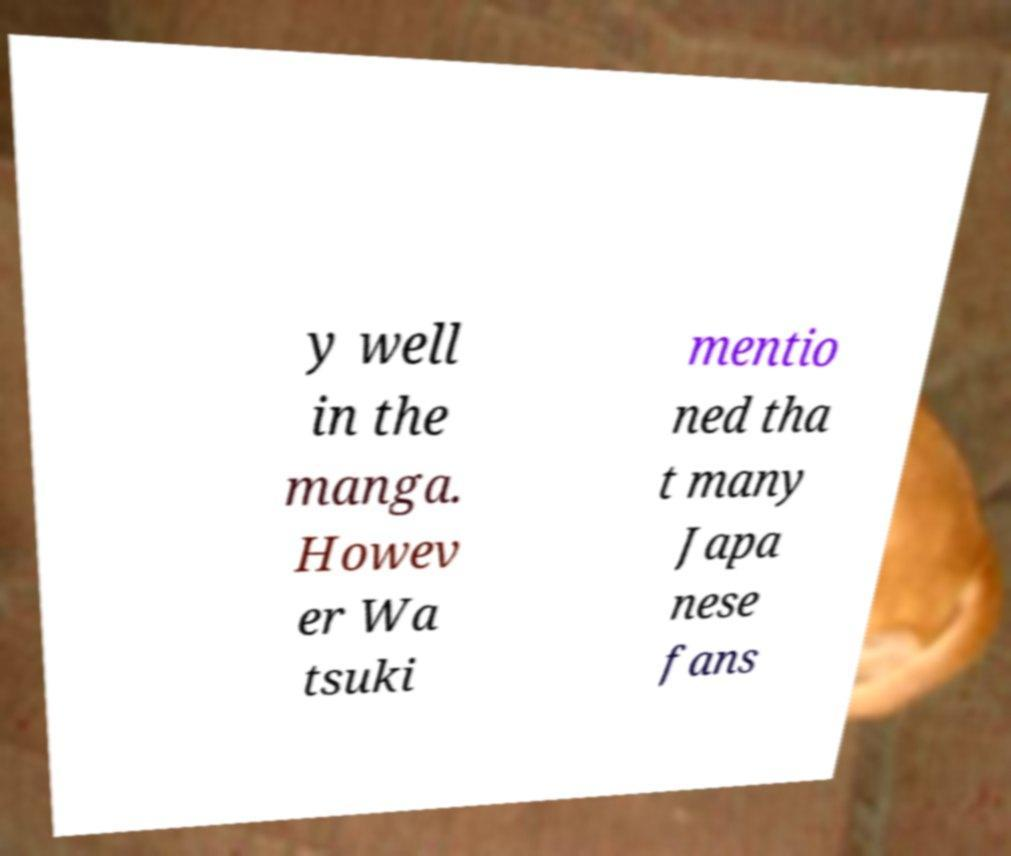Please read and relay the text visible in this image. What does it say? y well in the manga. Howev er Wa tsuki mentio ned tha t many Japa nese fans 